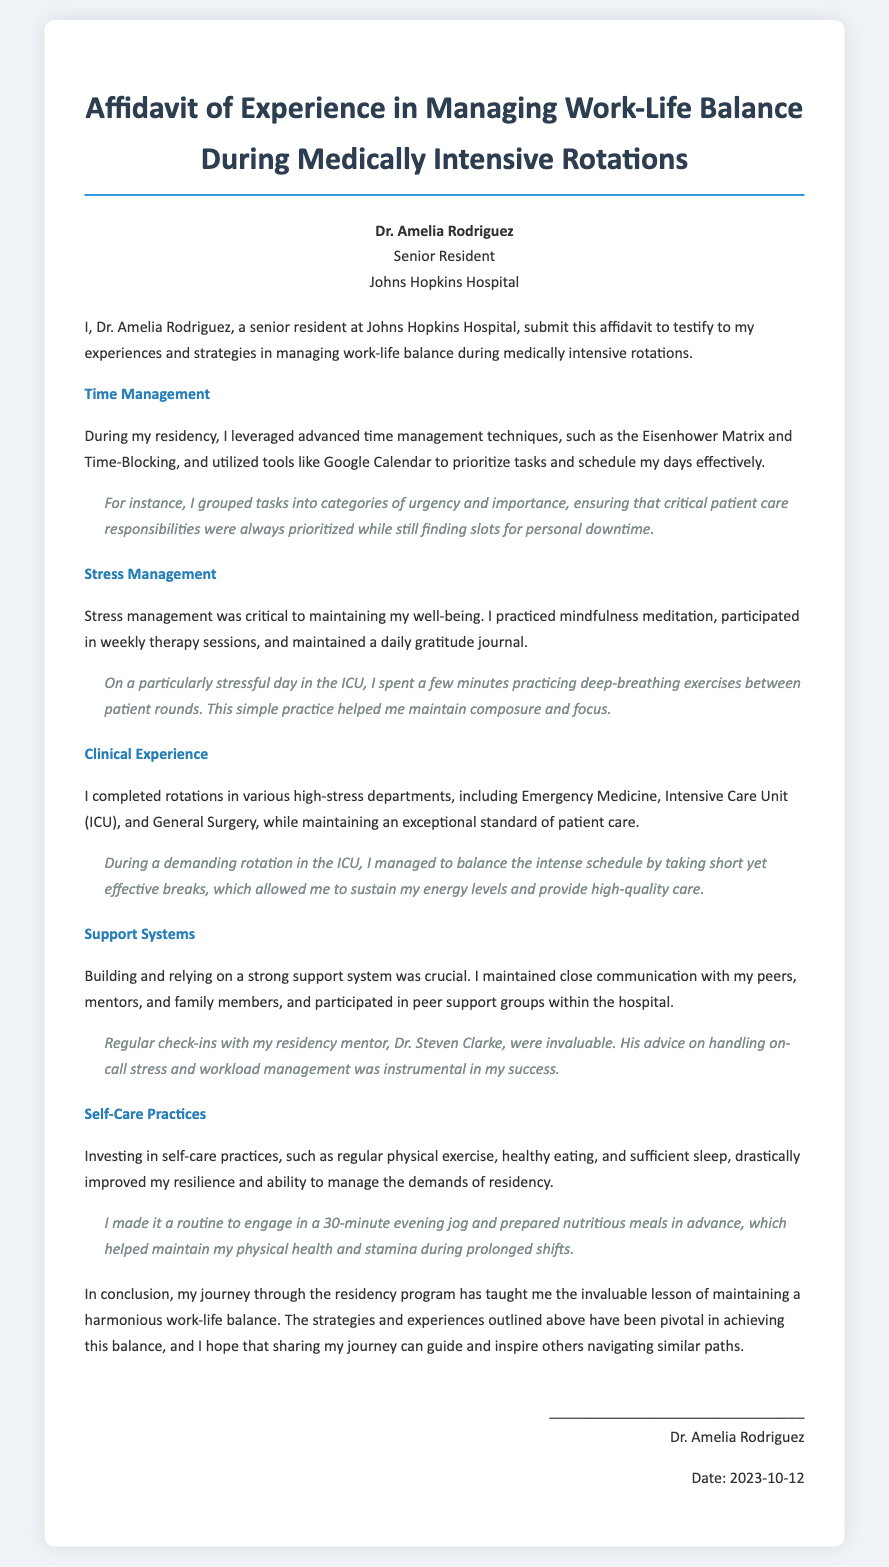What is the name of the declarant? The declarant's name is mentioned in the document's top section.
Answer: Dr. Amelia Rodriguez What institution is Dr. Amelia Rodriguez associated with? The document states Dr. Rodriguez's affiliation clearly in the declarant info section.
Answer: Johns Hopkins Hospital What date was the affidavit completed? The date is provided at the bottom of the document.
Answer: 2023-10-12 Which stress management technique is mentioned? The section on stress management lists various techniques used by the declarant.
Answer: Mindfulness meditation What specific example of time management is provided? The document includes an example explaining how the declarant prioritizes tasks.
Answer: Eisenhower Matrix What kind of support systems does Dr. Rodriguez mention? The document outlines various aspects of the support systems the declarant utilized.
Answer: Peer support groups How often did Dr. Rodriguez engage in therapy sessions? The stress management section highlights the frequency of therapy participation.
Answer: Weekly Which physical activity did Dr. Rodriguez include in her routine? The self-care practices section mentions a specific activity for physical health.
Answer: Evening jog What was the nature of the rotations completed by Dr. Rodriguez? The clinical experience section describes the settings in which the declarant trained.
Answer: High-stress departments 